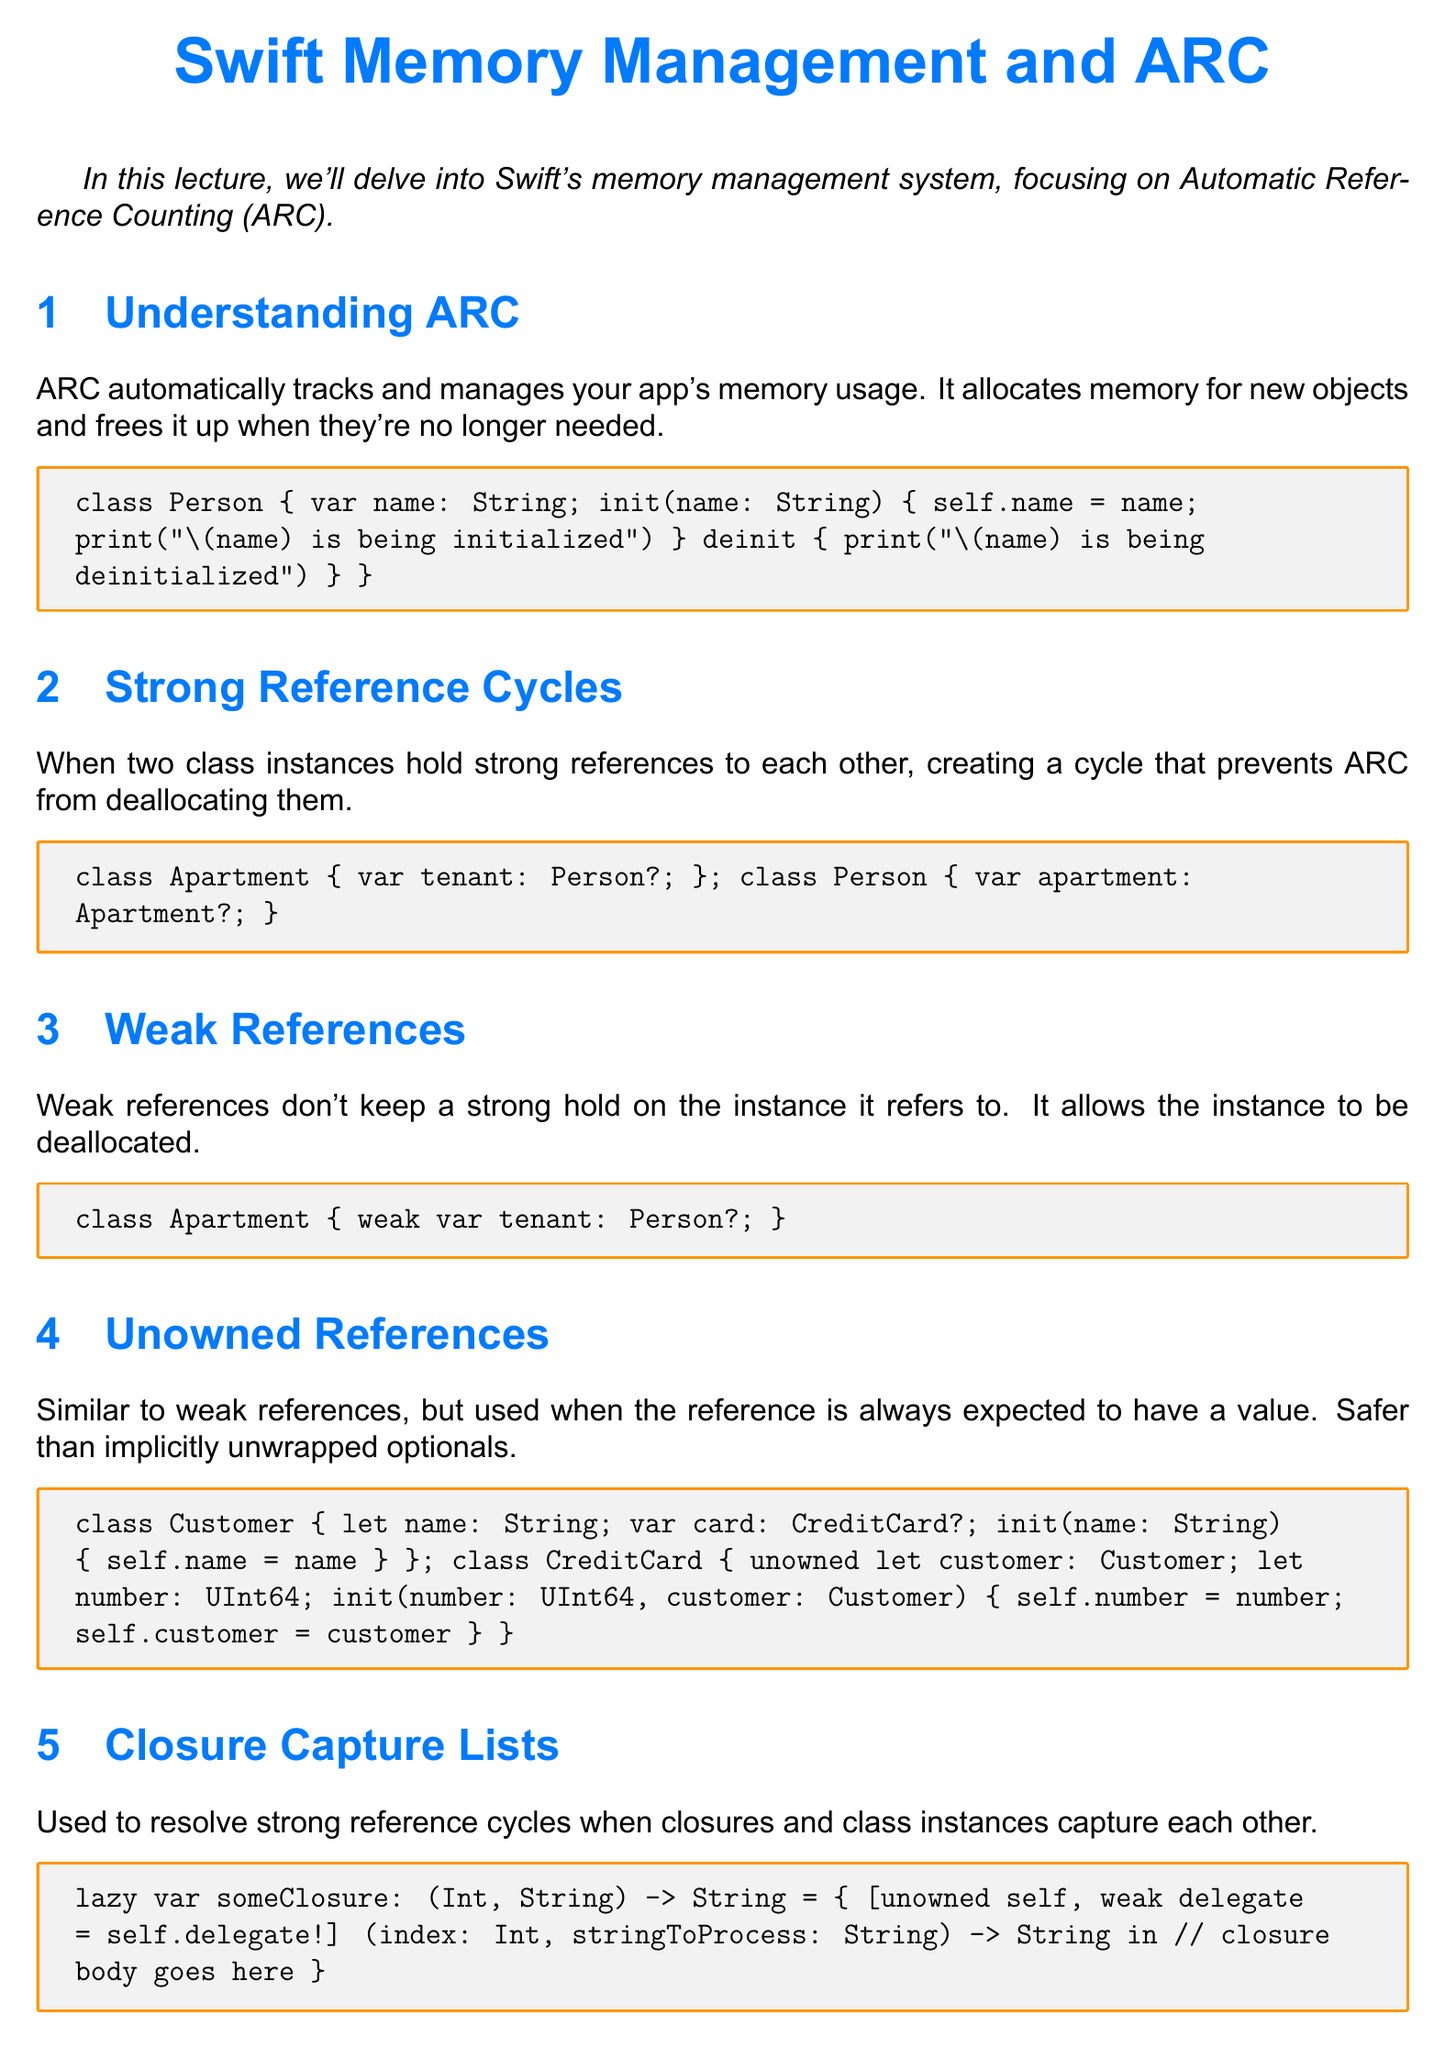What is the title of the lecture? The title of the lecture is the main subject of the document, which introduces the topic to be discussed.
Answer: Swift Memory Management and ARC What does ARC stand for? The acronym ARC in the context of the document refers to a specific memory management technique used in Swift.
Answer: Automatic Reference Counting What do strong reference cycles prevent? Strong reference cycles prevent a certain behavior in memory management in Swift, specifically regarding object deallocation.
Answer: ARC from deallocating them What type of reference allows an instance to be deallocated? This type of reference does not maintain a strong connection to the instance it refers to, allowing it to be deallocated.
Answer: Weak references What keyword is used for unowned references? The keyword specifically mentioned in the document that is used for creating unowned references is a single Swift keyword.
Answer: unowned What issue do closure capture lists resolve? The closure capture lists are used to address difficulties that arise primarily when certain entities interact with one another within closures.
Answer: Strong reference cycles How many sections are in the document? The sections outline the key points discussed in the lecture, including various aspects of memory management.
Answer: Five What is emphasized in the conclusion regarding memory management? The conclusion highlights an important practice that programmers should adhere to while writing applications in Swift.
Answer: Proper memory management 